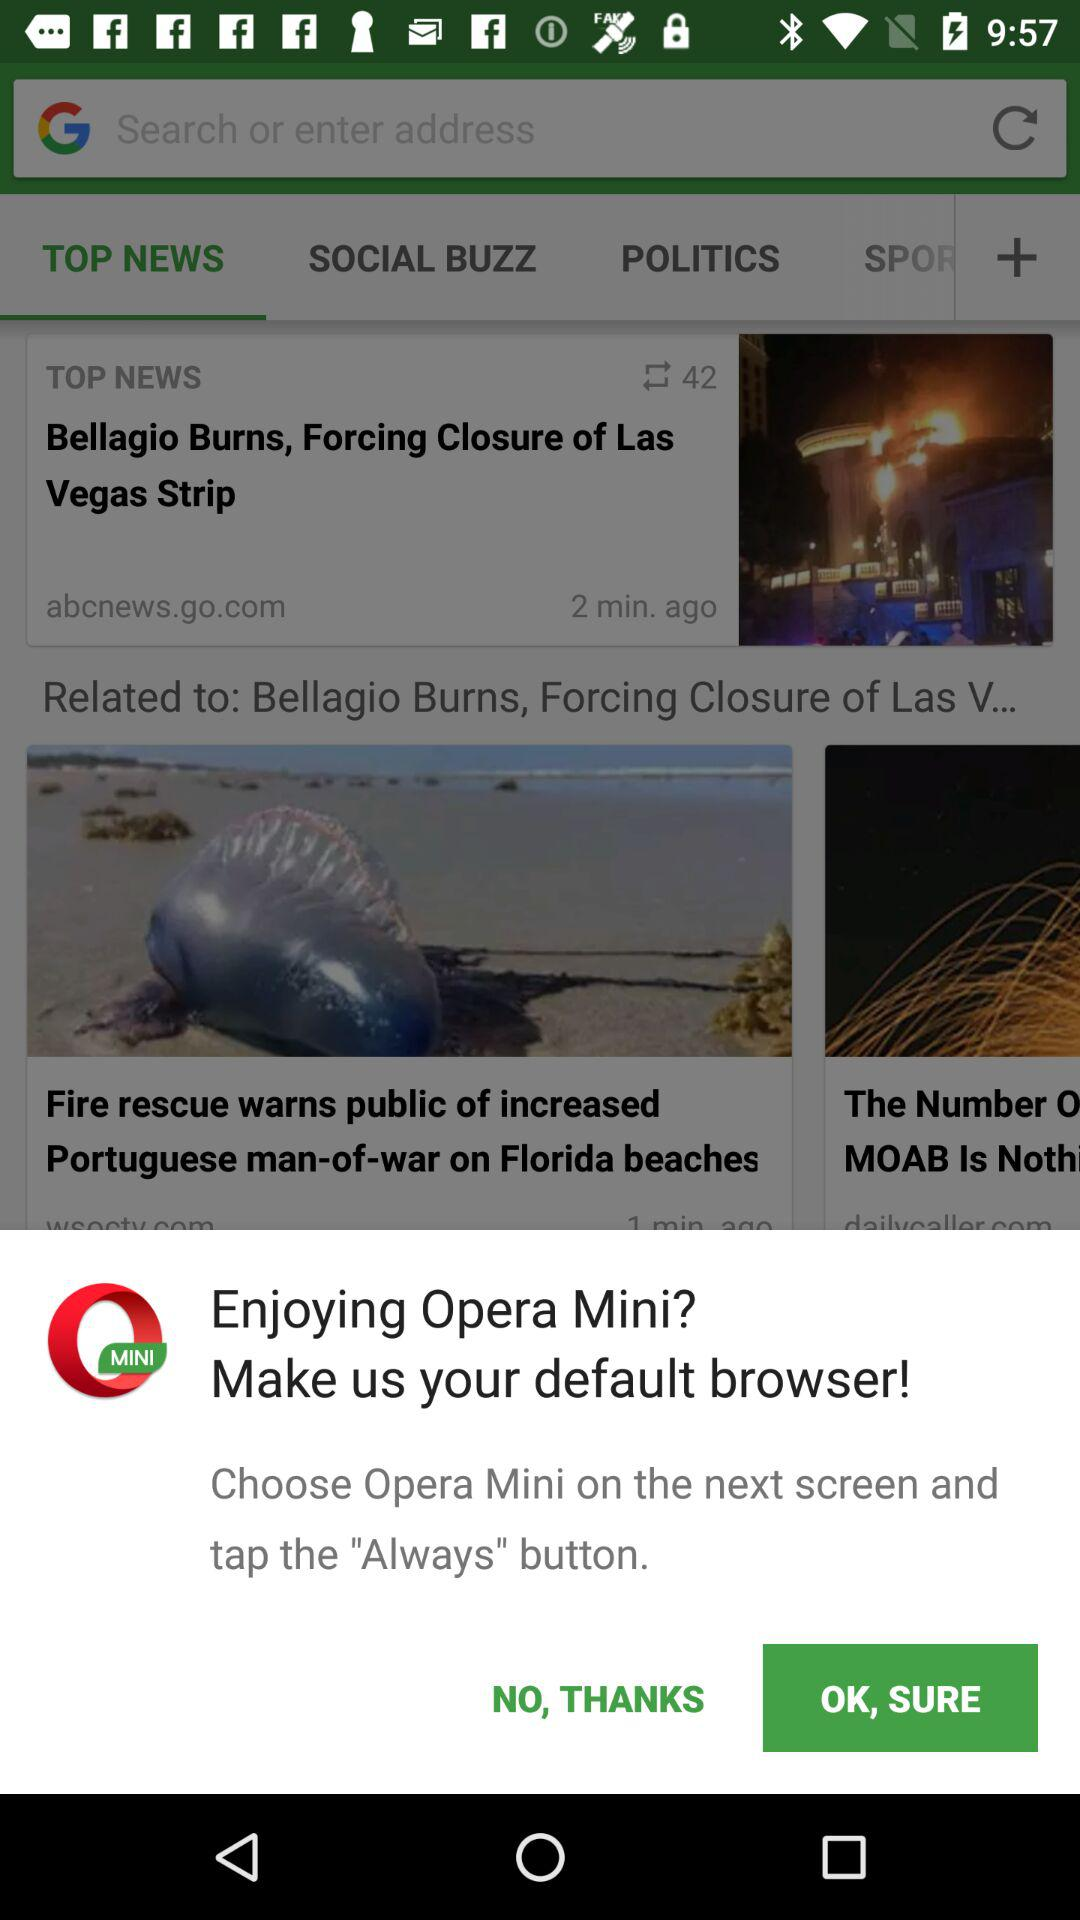What do we need to choose on the next screen? You need to choose "Opera Mini" on the next screen. 